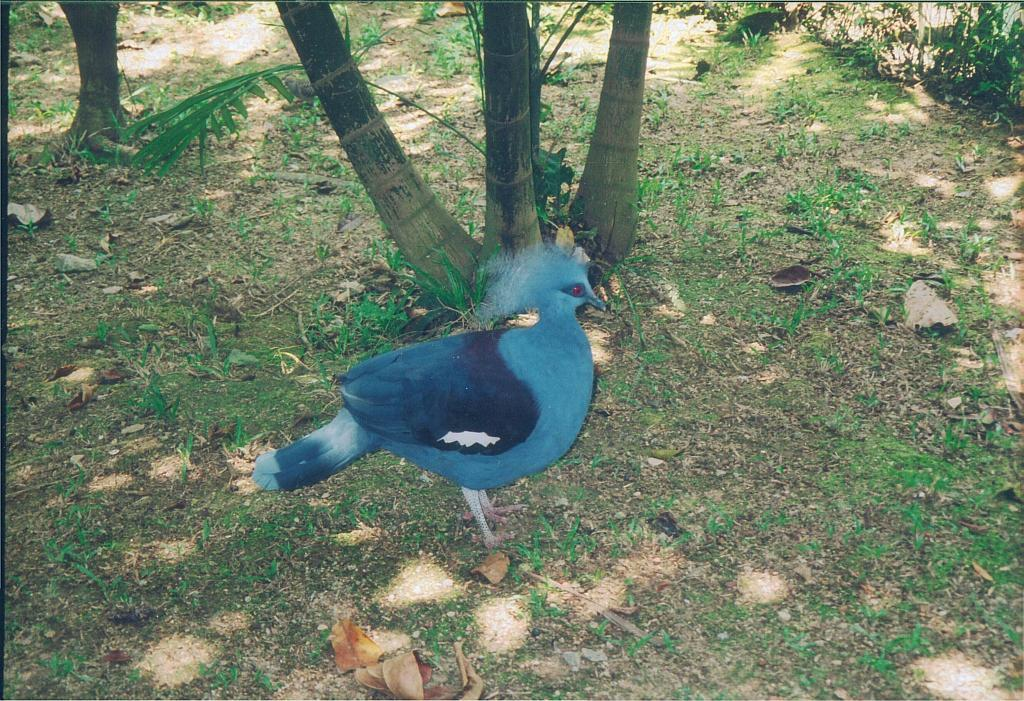What is the main subject in the middle of the image? There is a bird in the middle of the image. What can be seen in the background of the image? There are trees visible at the back side of the image. What type of dinner is being served in the image? There is no dinner present in the image; it features a bird and trees in the background. Can you see any veins or blood vessels on the bird in the image? The image does not show any veins or blood vessels on the bird; it is not possible to determine this information from the image. 